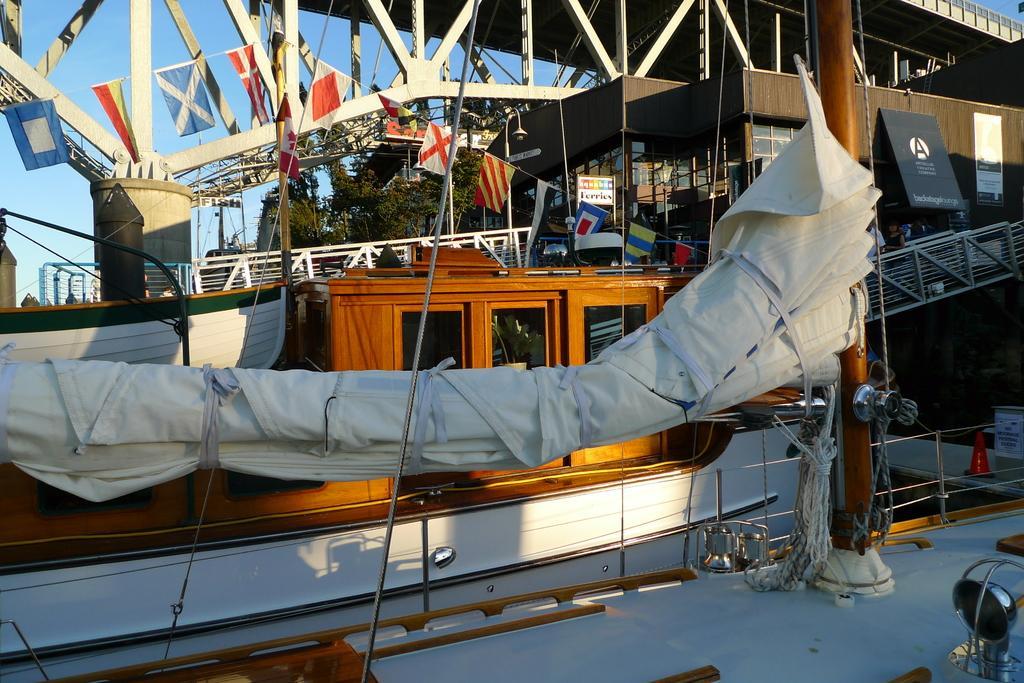How would you summarize this image in a sentence or two? Here we can see ships,ropes,windows,doors,poles,fence,a cloth rolled and tied with the rope and some other metal items. In the background we can see buildings,windows,posters on the wall,hoardings on the left side,trees,poles,bridge,fences,few persons,flags and sky. 